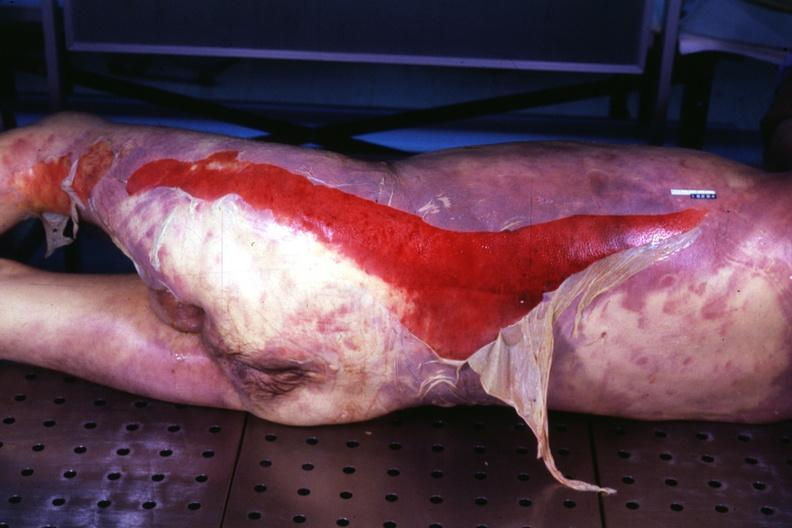does yellow color show portion of body with extensive skin desquamation same as in 907?
Answer the question using a single word or phrase. No 